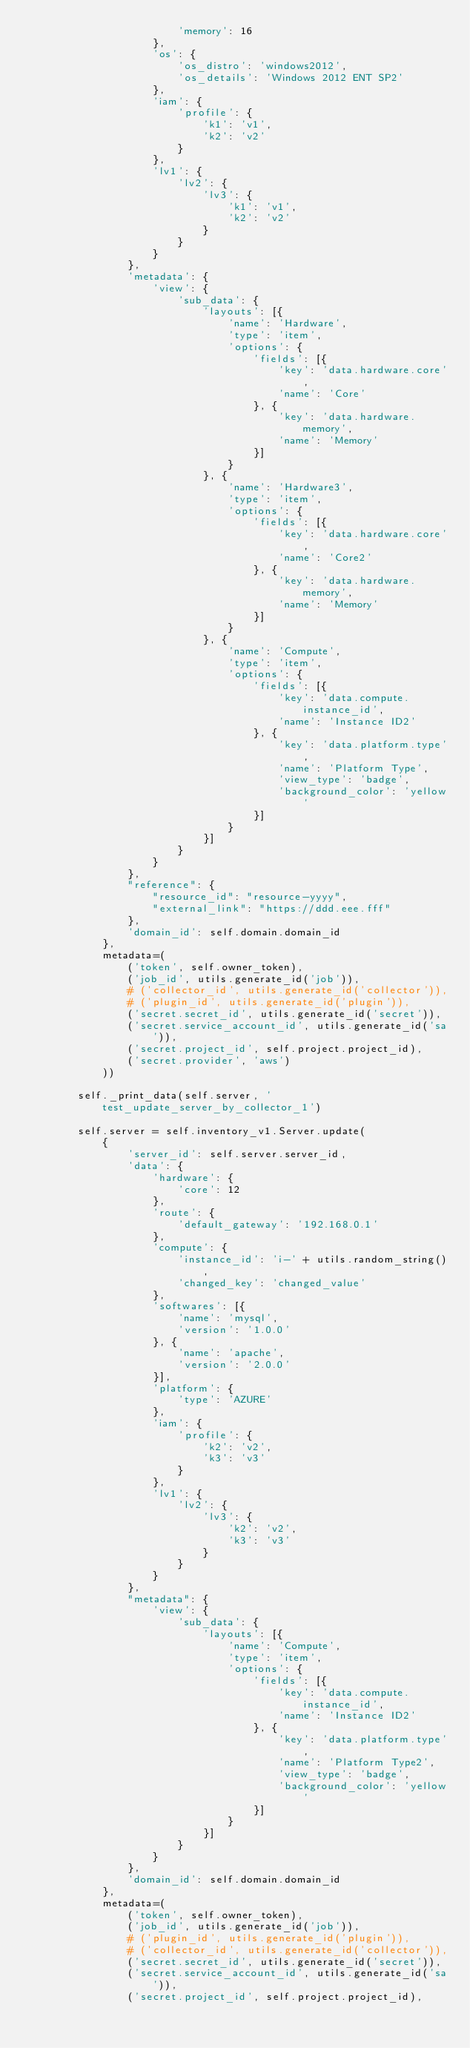Convert code to text. <code><loc_0><loc_0><loc_500><loc_500><_Python_>                        'memory': 16
                    },
                    'os': {
                        'os_distro': 'windows2012',
                        'os_details': 'Windows 2012 ENT SP2'
                    },
                    'iam': {
                        'profile': {
                            'k1': 'v1',
                            'k2': 'v2'
                        }
                    },
                    'lv1': {
                        'lv2': {
                            'lv3': {
                                'k1': 'v1',
                                'k2': 'v2'
                            }
                        }
                    }
                },
                'metadata': {
                    'view': {
                        'sub_data': {
                            'layouts': [{
                                'name': 'Hardware',
                                'type': 'item',
                                'options': {
                                    'fields': [{
                                        'key': 'data.hardware.core',
                                        'name': 'Core'
                                    }, {
                                        'key': 'data.hardware.memory',
                                        'name': 'Memory'
                                    }]
                                }
                            }, {
                                'name': 'Hardware3',
                                'type': 'item',
                                'options': {
                                    'fields': [{
                                        'key': 'data.hardware.core',
                                        'name': 'Core2'
                                    }, {
                                        'key': 'data.hardware.memory',
                                        'name': 'Memory'
                                    }]
                                }
                            }, {
                                'name': 'Compute',
                                'type': 'item',
                                'options': {
                                    'fields': [{
                                        'key': 'data.compute.instance_id',
                                        'name': 'Instance ID2'
                                    }, {
                                        'key': 'data.platform.type',
                                        'name': 'Platform Type',
                                        'view_type': 'badge',
                                        'background_color': 'yellow'
                                    }]
                                }
                            }]
                        }
                    }
                },
                "reference": {
                    "resource_id": "resource-yyyy",
                    "external_link": "https://ddd.eee.fff"
                },
                'domain_id': self.domain.domain_id
            },
            metadata=(
                ('token', self.owner_token),
                ('job_id', utils.generate_id('job')),
                # ('collector_id', utils.generate_id('collector')),
                # ('plugin_id', utils.generate_id('plugin')),
                ('secret.secret_id', utils.generate_id('secret')),
                ('secret.service_account_id', utils.generate_id('sa')),
                ('secret.project_id', self.project.project_id),
                ('secret.provider', 'aws')
            ))

        self._print_data(self.server, 'test_update_server_by_collector_1')

        self.server = self.inventory_v1.Server.update(
            {
                'server_id': self.server.server_id,
                'data': {
                    'hardware': {
                        'core': 12
                    },
                    'route': {
                        'default_gateway': '192.168.0.1'
                    },
                    'compute': {
                        'instance_id': 'i-' + utils.random_string(),
                        'changed_key': 'changed_value'
                    },
                    'softwares': [{
                        'name': 'mysql',
                        'version': '1.0.0'
                    }, {
                        'name': 'apache',
                        'version': '2.0.0'
                    }],
                    'platform': {
                        'type': 'AZURE'
                    },
                    'iam': {
                        'profile': {
                            'k2': 'v2',
                            'k3': 'v3'
                        }
                    },
                    'lv1': {
                        'lv2': {
                            'lv3': {
                                'k2': 'v2',
                                'k3': 'v3'
                            }
                        }
                    }
                },
                "metadata": {
                    'view': {
                        'sub_data': {
                            'layouts': [{
                                'name': 'Compute',
                                'type': 'item',
                                'options': {
                                    'fields': [{
                                        'key': 'data.compute.instance_id',
                                        'name': 'Instance ID2'
                                    }, {
                                        'key': 'data.platform.type',
                                        'name': 'Platform Type2',
                                        'view_type': 'badge',
                                        'background_color': 'yellow'
                                    }]
                                }
                            }]
                        }
                    }
                },
                'domain_id': self.domain.domain_id
            },
            metadata=(
                ('token', self.owner_token),
                ('job_id', utils.generate_id('job')),
                # ('plugin_id', utils.generate_id('plugin')),
                # ('collector_id', utils.generate_id('collector')),
                ('secret.secret_id', utils.generate_id('secret')),
                ('secret.service_account_id', utils.generate_id('sa')),
                ('secret.project_id', self.project.project_id),</code> 